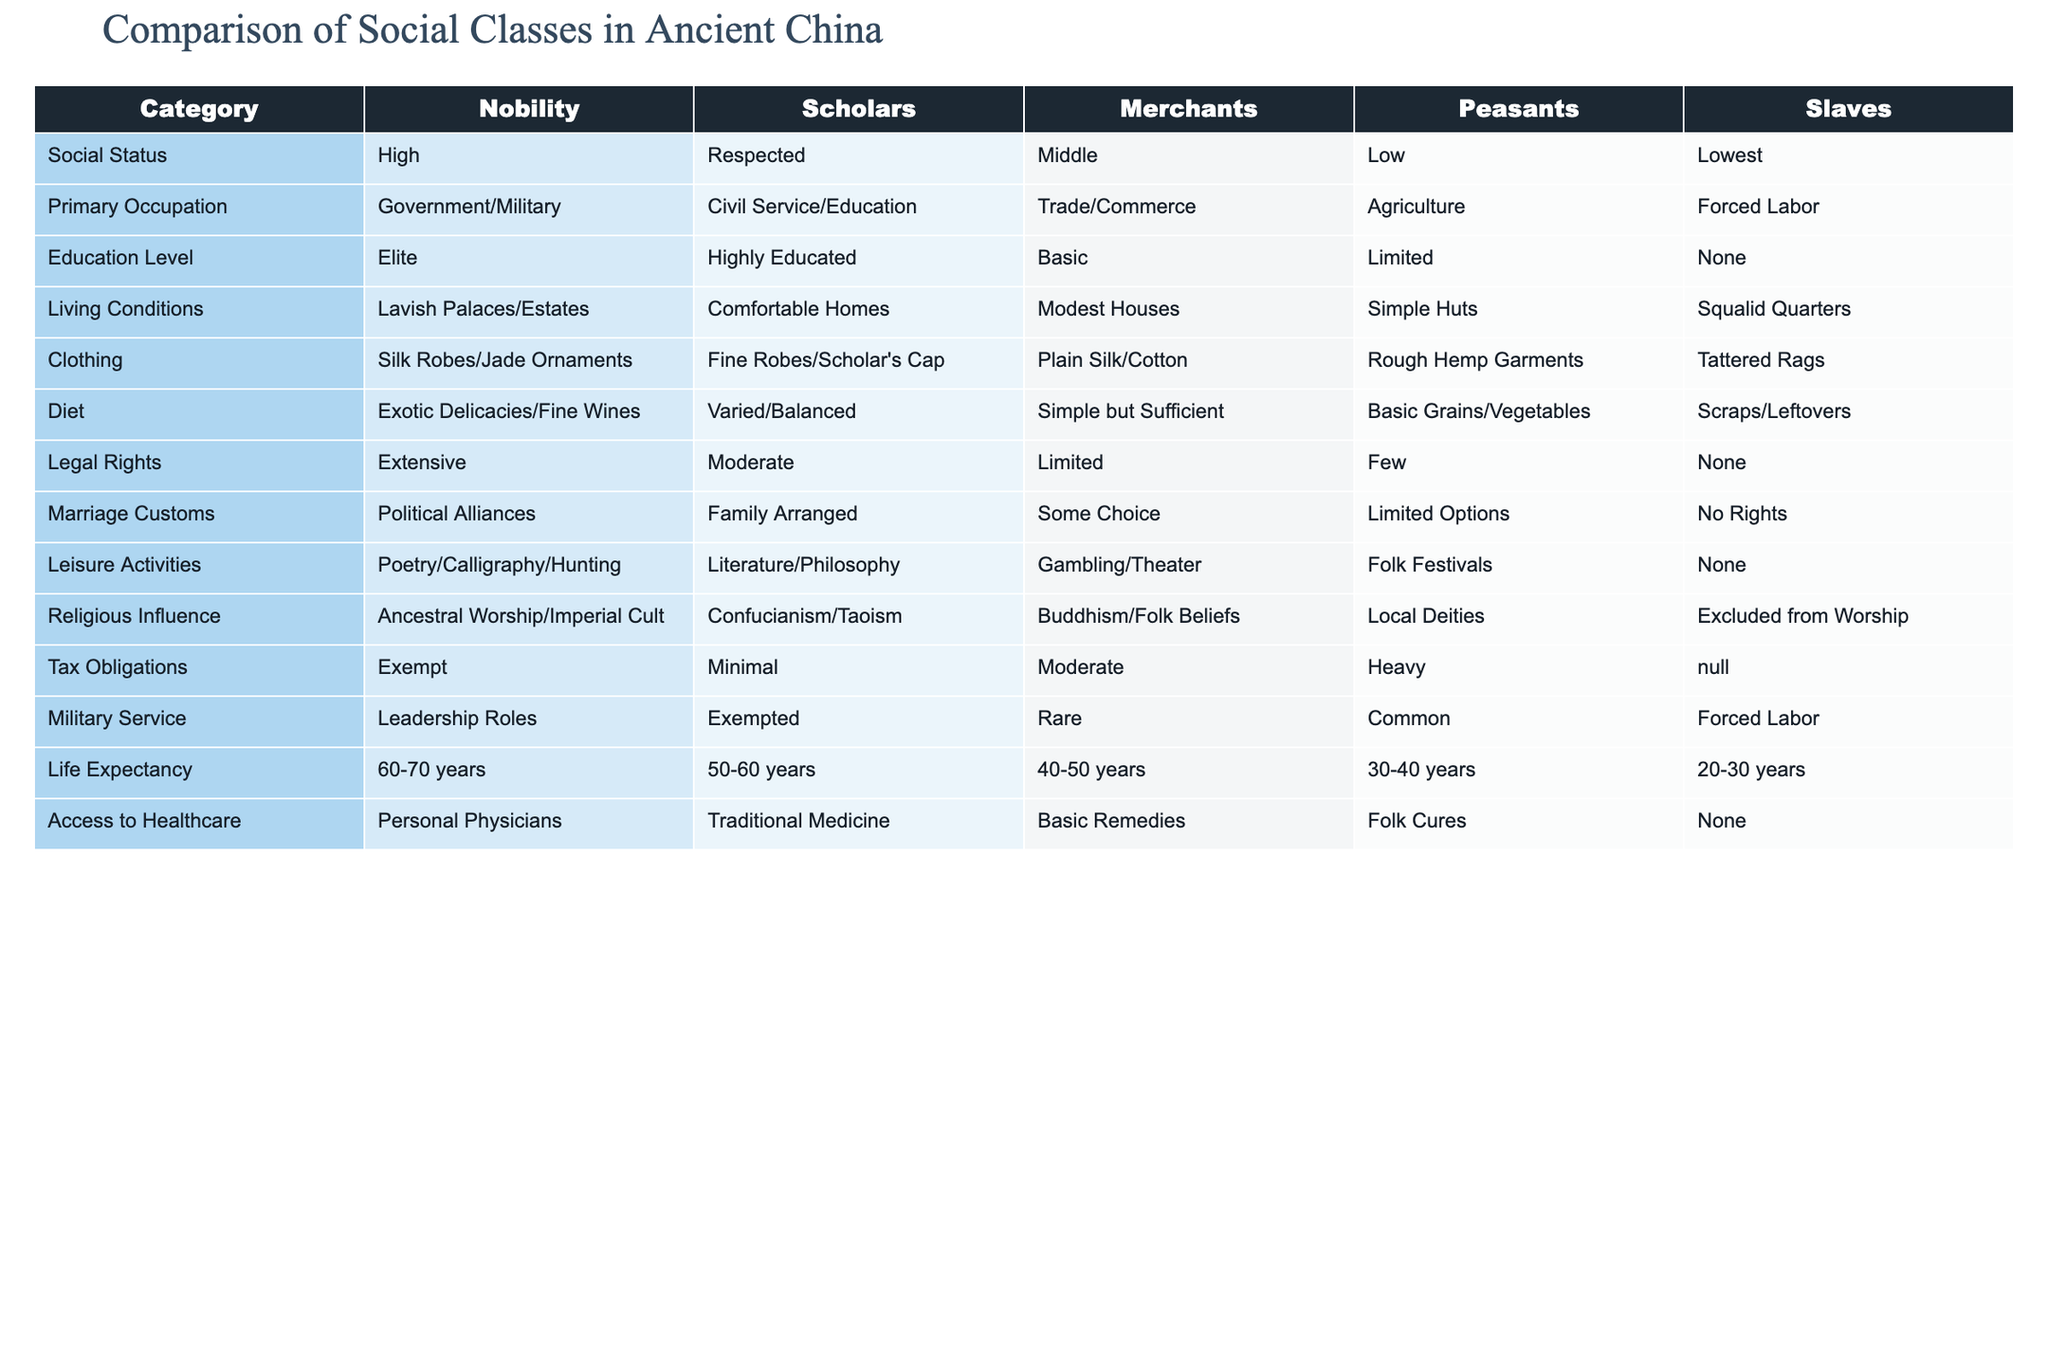What is the primary occupation of the Nobility? The table states that the primary occupation of the Nobility is Government/Military.
Answer: Government/Military How do the leisure activities of Scholars compare to those of Peasants? According to the table, Scholars engage in Literature/Philosophy, while Peasants participate in Folk Festivals. This indicates that Scholars have more intellectual leisure pursuits compared to the simpler gatherings of Peasants.
Answer: Scholars engage in Literature/Philosophy while Peasants participate in Folk Festivals Do Merchants have legal rights? The table shows that Merchants have Limited legal rights.
Answer: Yes, Merchants have limited legal rights What is the average life expectancy of Peasants compared to Nobility? The life expectancy for Peasants is stated as 30-40 years, while for Nobility it is 60-70 years. To find the average, we can take the average of the ranges: Nobility (65 years) and Peasants (35 years), which indicates that Nobility lives significantly longer than Peasants.
Answer: Nobility has an average of 65 years and Peasants have an average of 35 years What are the living conditions of Merchants compared to Scholars? Living conditions for Merchants are described as Modest Houses, whereas Scholars have Comfortable Homes. This indicates that Scholars enjoy better living conditions compared to Merchants.
Answer: Scholars have better living conditions than Merchants Is it true that Slaves have any legal rights? The table indicates that Slaves have None for legal rights, which confirms that they do not have any legal protections.
Answer: No, Slaves have no legal rights How do diet options differ between Nobility and Merchants? Nobility's diet consists of Exotic Delicacies/Fine Wines, while Merchants have a Simple but Sufficient diet. This demonstrates a significant disparity in the quality and variety of food available to each class.
Answer: Nobility's diet is Exotic Delicacies/Fine Wines, while Merchants have Simple but Sufficient food What can we infer about the Military Service obligations for each class? Nobility are in Leadership Roles, Scholars are Exempted, Merchants serve Rarely, Peasants serve Commonly, and Slaves are subject to Forced Labor. This shows a clear hierarchy in military obligations with Nobility at the top.
Answer: Nobility has Leadership Roles while Peasants serve Commonly What percentage of Merchants have access to personal physicians compared to Nobility? The table shows that Nobility have Personal Physicians while Merchants only have Basic Remedies. This suggests that Nobility have significantly greater access to healthcare resources compared to Merchants.
Answer: Nobility have personal physicians, whereas Merchants have basic remedies 